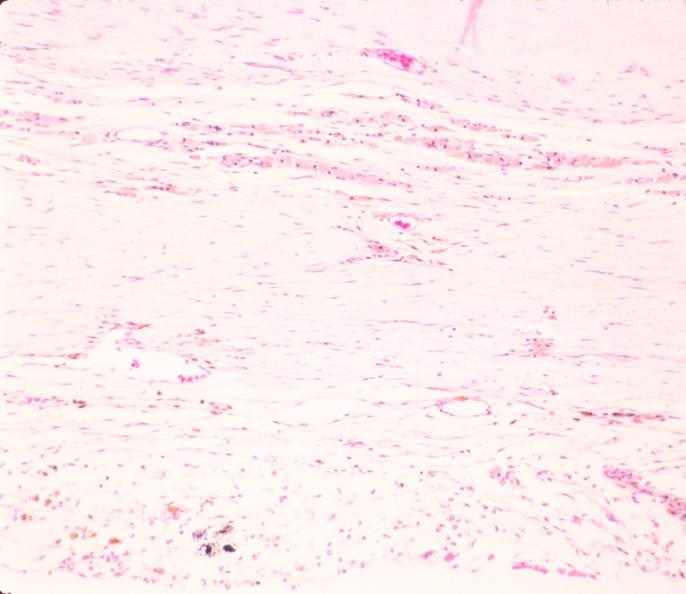what is present?
Answer the question using a single word or phrase. Nervous 